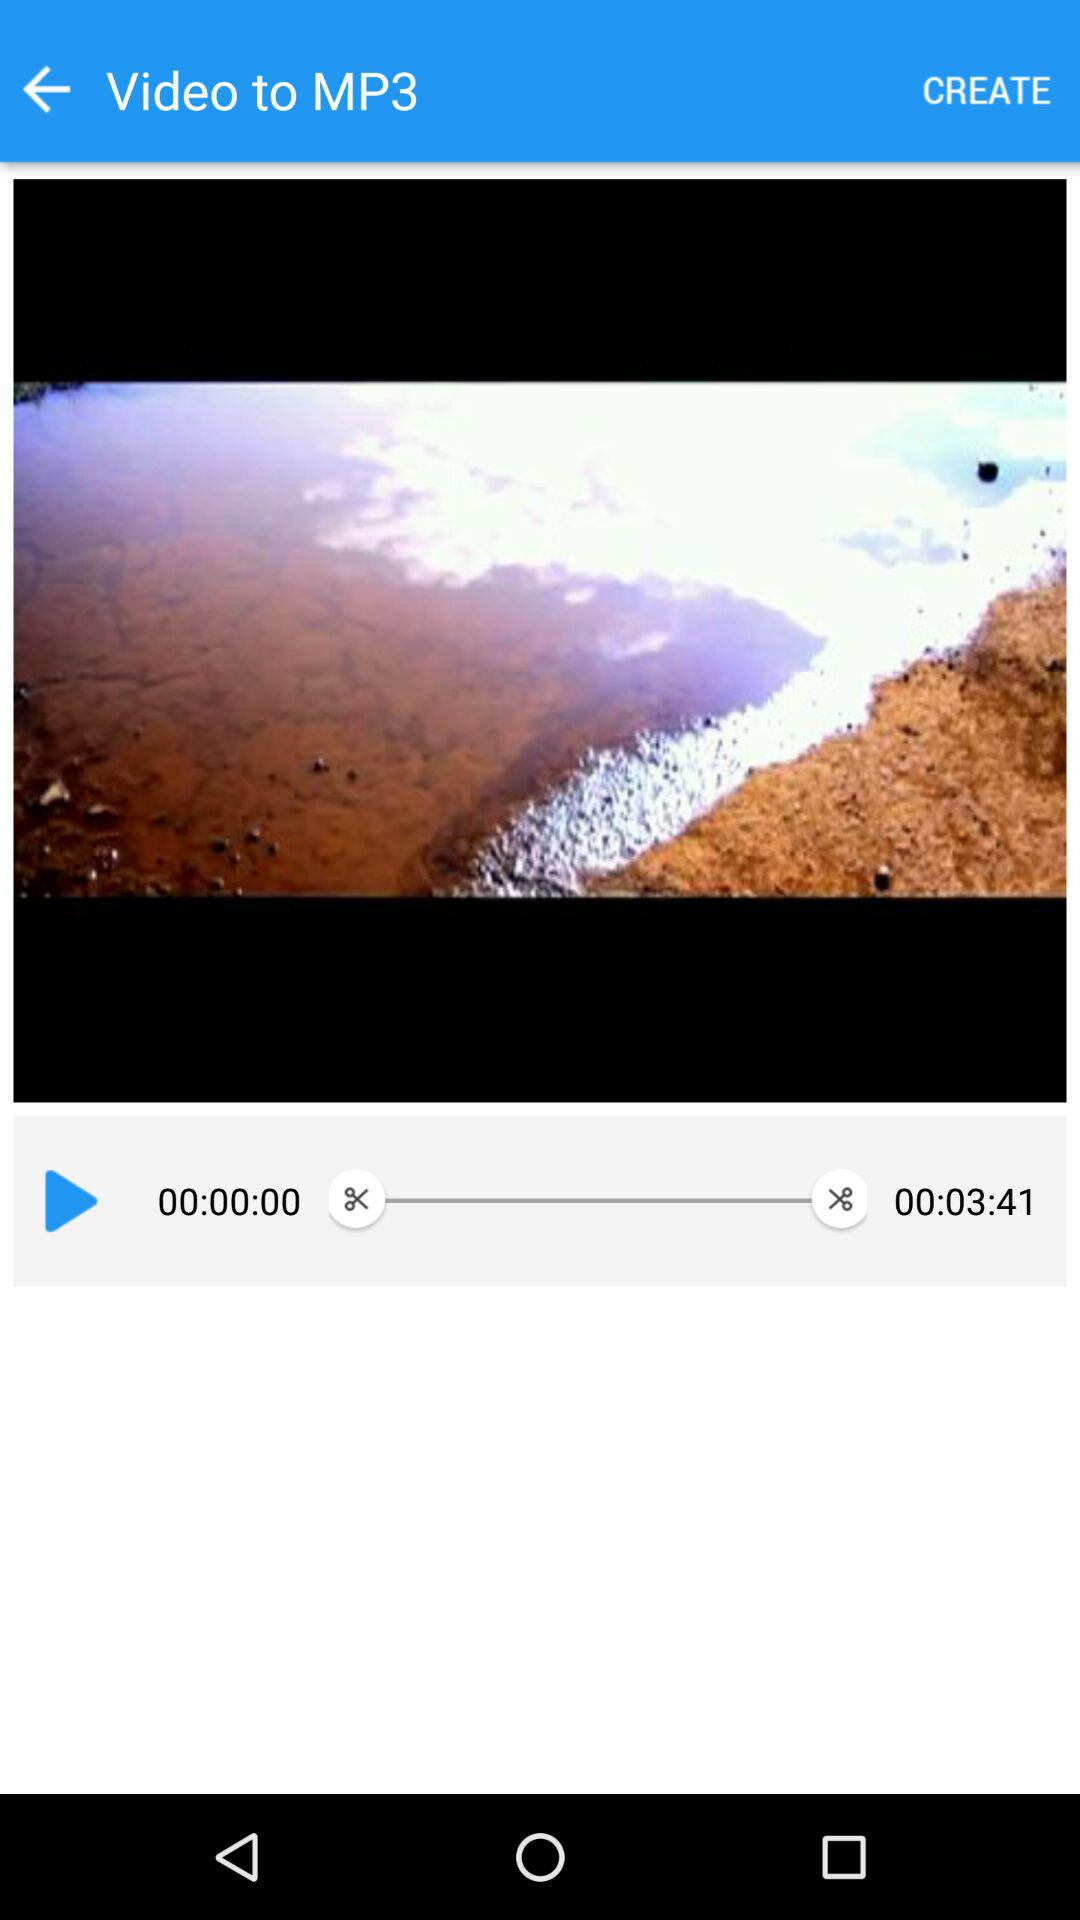What conversion is being performed? The conversion that is being performed is "Video to MP3". 